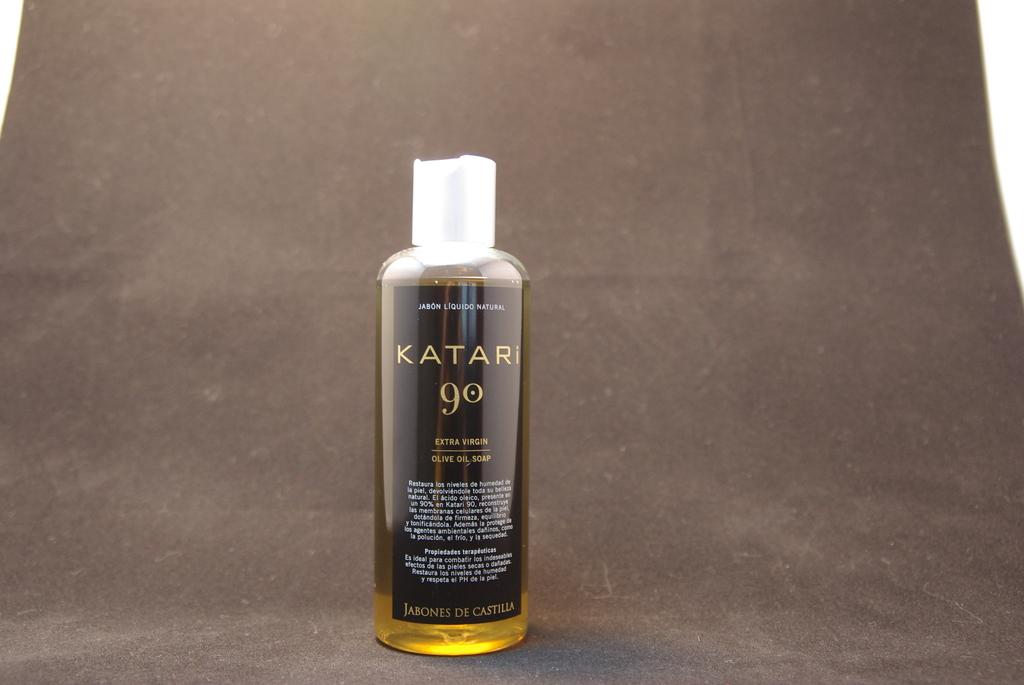<image>
Describe the image concisely. A KATAR Go bottle filled with extra virgin olive oil soap stands on display. 